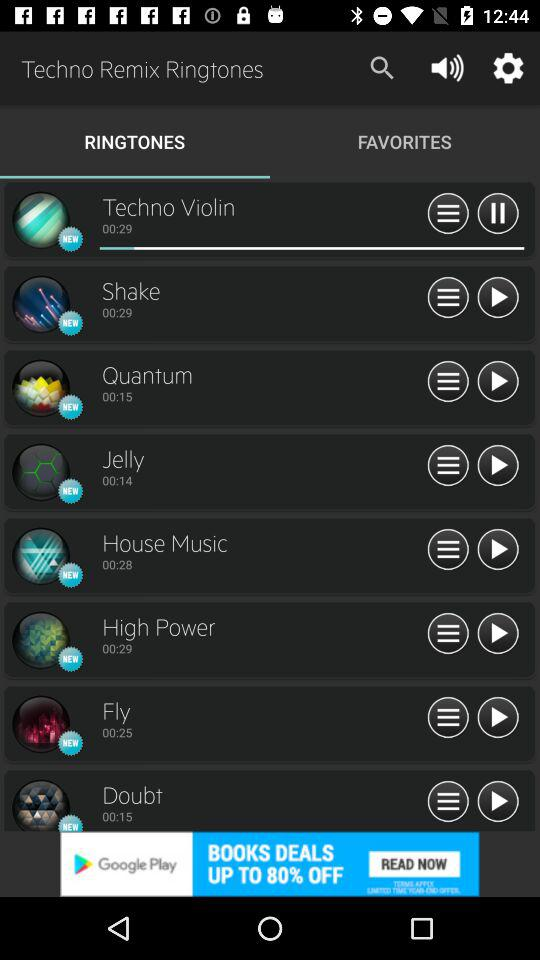What's the duration of the "Jelly" ringtone? The duration is 14 seconds. 